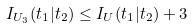Convert formula to latex. <formula><loc_0><loc_0><loc_500><loc_500>I _ { U _ { 3 } } ( t _ { 1 } | t _ { 2 } ) \leq I _ { U } ( t _ { 1 } | t _ { 2 } ) + 3</formula> 